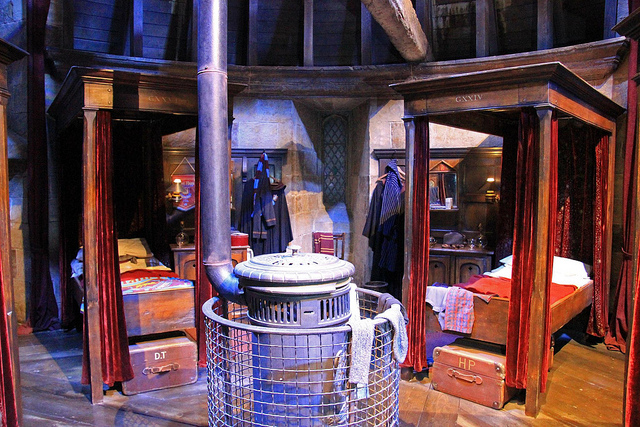Read all the text in this image. HP D.T CXXIV 